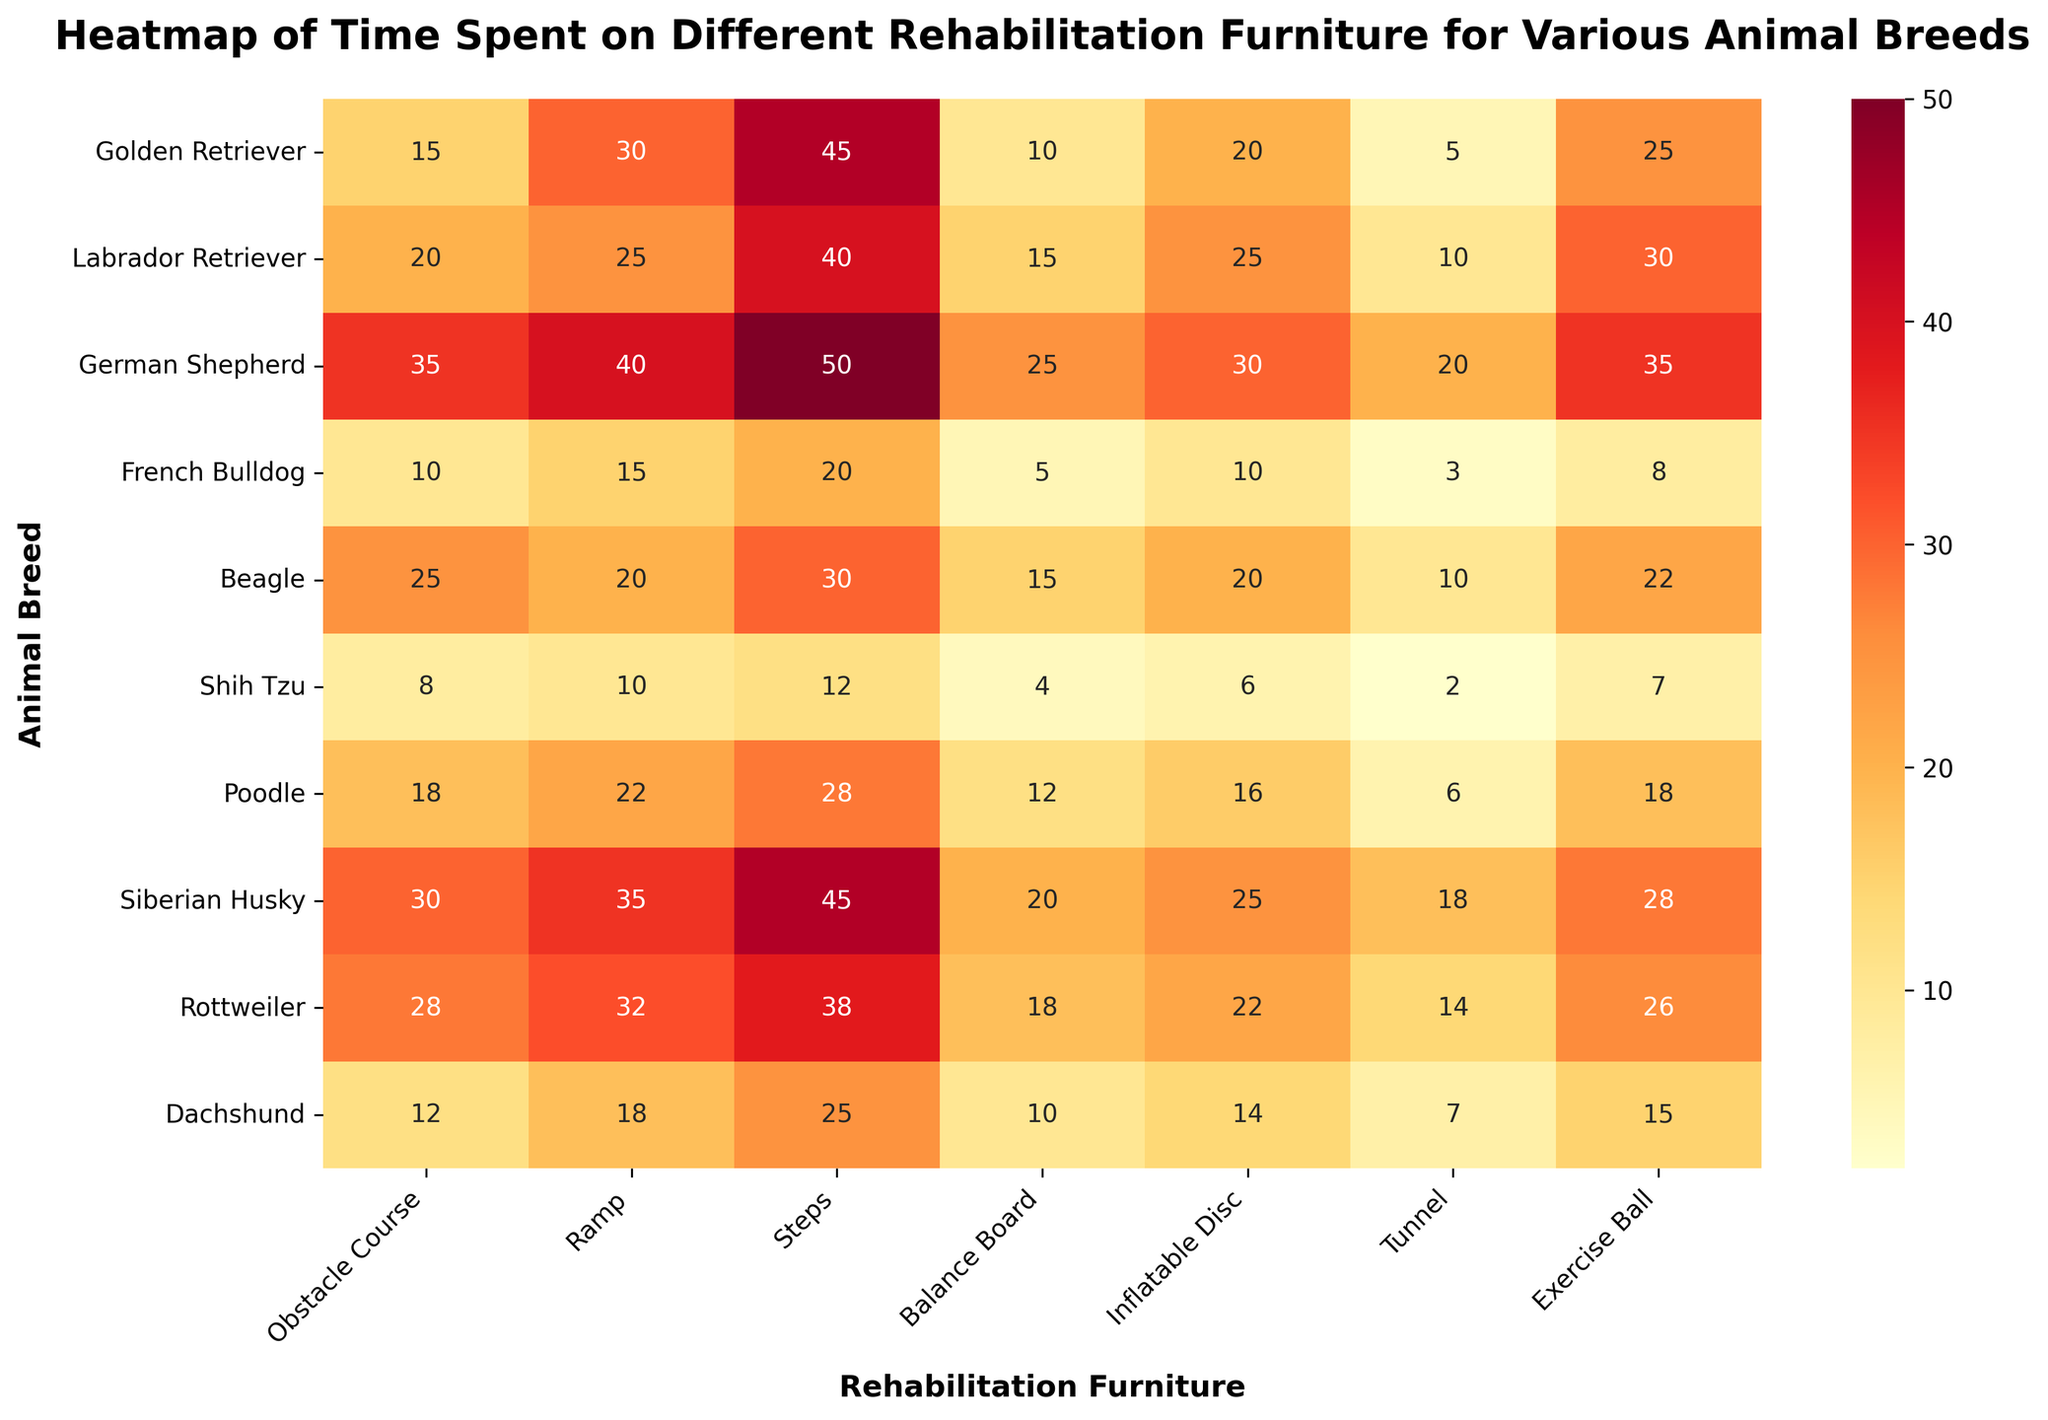What is the title of the heatmap? The title is usually located at the top of the figure in bold and larger font size. It reads: "Heatmap of Time Spent on Different Rehabilitation Furniture for Various Animal Breeds".
Answer: Heatmap of Time Spent on Different Rehabilitation Furniture for Various Animal Breeds How much time does a German Shepherd spend on the balance board? Locate the row for "German Shepherd" and then find the corresponding cell under the "Balance Board" column. The value in that cell is 25 minutes.
Answer: 25 minutes Which animal breed spends the most time on the exercise ball? Scan the "Exercise Ball" column to find the largest value and then identify the corresponding animal breed. The highest value is 35, which is for "German Shepherd".
Answer: German Shepherd What is the total time a Beagle spends on all rehabilitation furniture combined? Add all the values in the row for "Beagle": 25 (Obstacle Course) + 20 (Ramp) + 30 (Steps) + 15 (Balance Board) + 20 (Inflatable Disc) + 10 (Tunnel) + 22 (Exercise Ball) = 142 minutes.
Answer: 142 minutes How much longer does a Rottweiler spend on the tunnel compared to a Shih Tzu? Find the values for "Tunnel" in the rows for "Rottweiler" and "Shih Tzu". Subtract the latter from the former: 14 (Rottweiler) - 2 (Shih Tzu) = 12 minutes.
Answer: 12 minutes Which two types of rehabilitation furniture do Golden Retrievers and Labrador Retrievers spend the most time on, respectively? In the row for "Golden Retriever," the highest values are "Steps" with 45 minutes. In the row for "Labrador Retriever," the highest value is also "Steps" with 40 minutes.
Answer: Steps for both What is the median time spent on the ramp across all animal breeds? Extract all values from the "Ramp" column: 30, 25, 40, 15, 20, 10, 22, 35, 32, 18. Sort them and find the middle value(s): sorted values are 10, 15, 18, 20, 22, 25, 30, 32, 35, 40. The median is the average of 22 and 25: (22+25)/2 = 23.5 minutes.
Answer: 23.5 minutes Which animal breed spends the least amount of time on the obstacle course? Scan the "Obstacle Course" column to find the smallest value and identify the corresponding animal breed: The lowest value is 8 for "Shih Tzu".
Answer: Shih Tzu Compare the time spent on the inflatable disc between a Siberian Husky and a Dachshund, and state the difference. Find the values for "Inflatable Disc" in the rows for "Siberian Husky" and "Dachshund". Subtract the latter from the former: 25 (Siberian Husky) - 14 (Dachshund) = 11 minutes.
Answer: 11 minutes Which type of rehabilitation furniture has the most variability in time spent across all breeds? To determine variability, compare the range (high value - low value) of times in each column. "Obstacle Course" range is (35-8)=27, "Ramp" range is (40-10)=30, "Steps" range is (50-12)=38, "Balance Board" range is (25-4)=21, "Inflatable Disc" range is (30-6)=24, "Tunnel" range is (20-2)=18, and "Exercise Ball" range is (35-7)=28. The "Steps" column has the highest range of 38, indicating the most variability.
Answer: Steps 